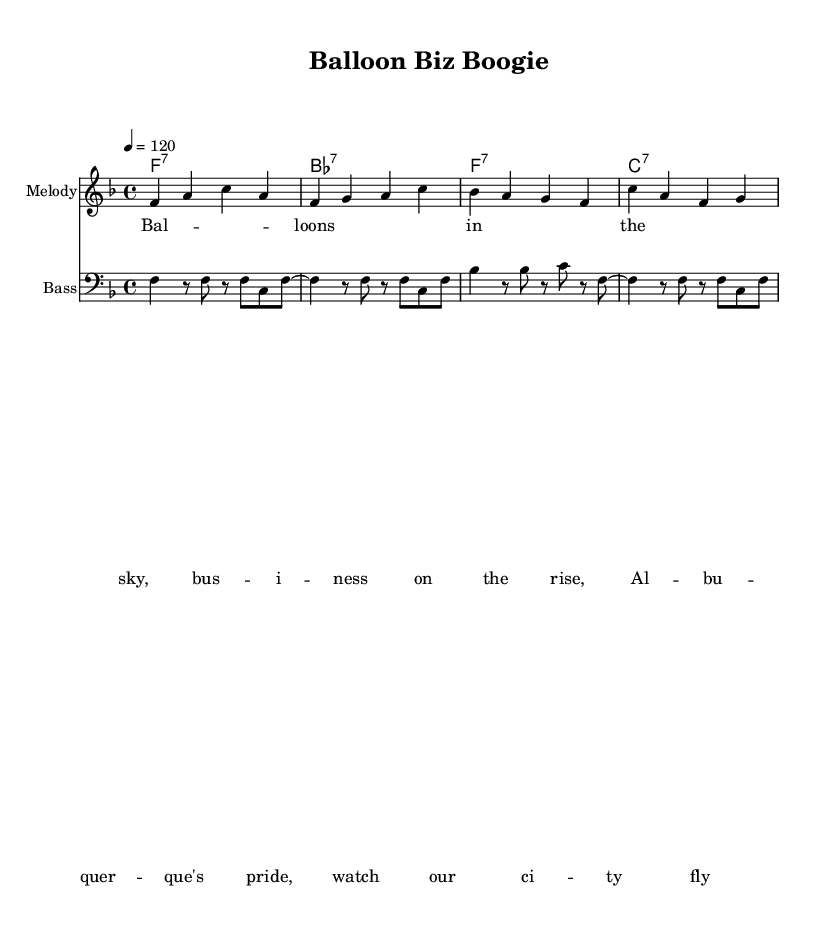What is the key signature of this music? The key signature is indicated by the signature symbols at the beginning of the staff. In this case, there are no sharps or flats, which signifies that the key is F major.
Answer: F major What is the time signature of this music? The time signature is found at the beginning of the sheet music, indicating how many beats are in each measure. Here, it shows 4/4, meaning there are four beats in a measure and a quarter note gets one beat.
Answer: 4/4 What is the tempo marking of this piece? The tempo is specified at the beginning of the score with a number indicating beats per minute. It shows "4 = 120", meaning the quarter note is played at 120 beats per minute.
Answer: 120 Identify the first chord played in the piece. The first chord is found in the chord names section at the start of the score. It is listed as "f:7", indicating the first chord is an F7 chord.
Answer: F7 How many measures are in the melody? To find the number of measures in the melody, count the vertical lines that separate each measure in the melody's staff. There are four measures in total.
Answer: 4 What type of lyrics are associated with this music piece? The lyrics are associated with the music in a specific format meant for performance. In this case, it includes a lyrical theme about balloons and local pride, indicated as standard lyrics under the melody.
Answer: Standard lyrics What genre of music does this sheet music represent? This sheet music represents Funk, which is characterized by its groovy bass lines and rhythmic patterns. The title and musical style further suggest this genre focused on celebration and a fun, energetic vibe.
Answer: Funk 